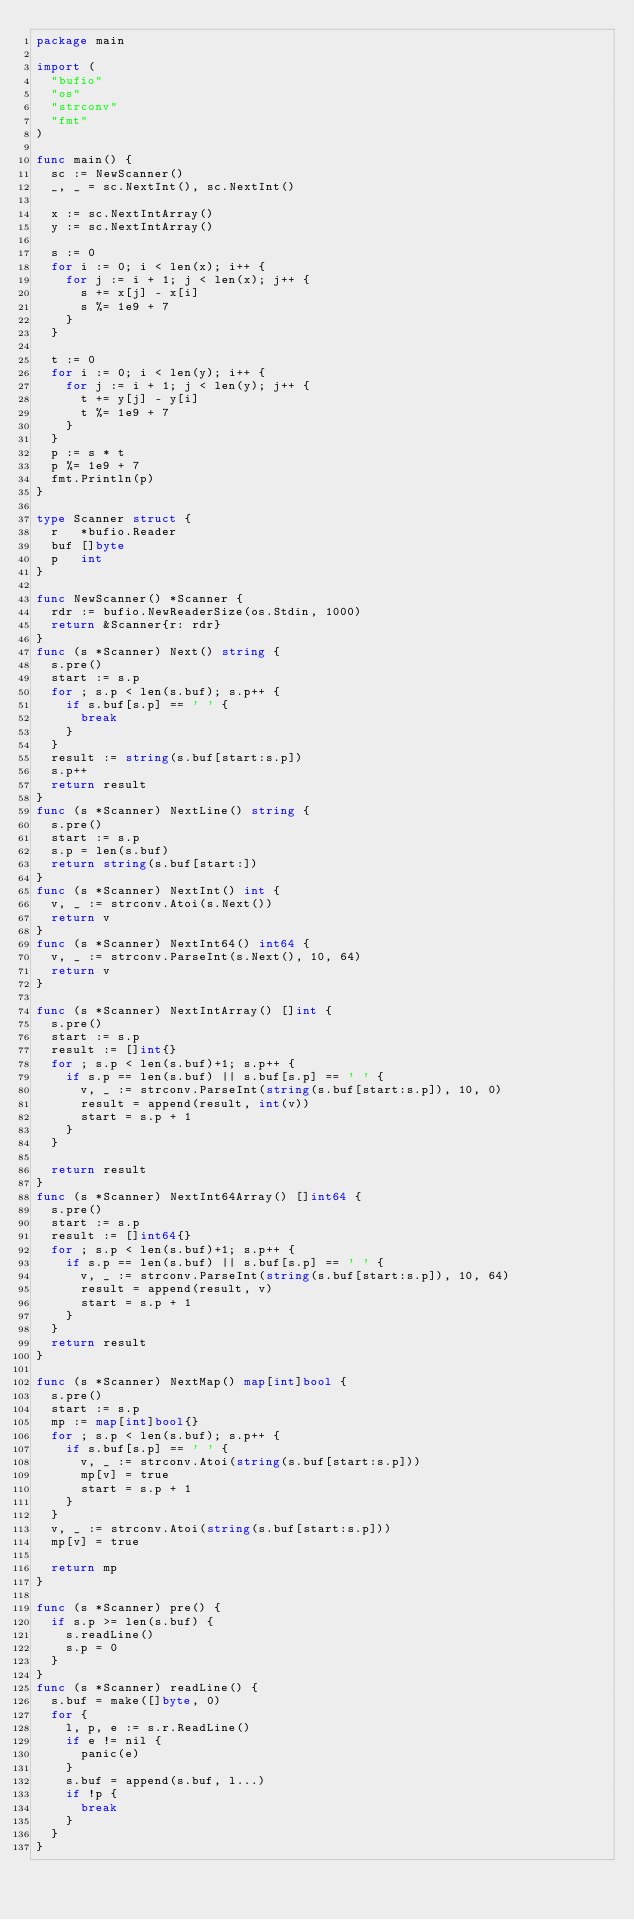<code> <loc_0><loc_0><loc_500><loc_500><_Go_>package main

import (
	"bufio"
	"os"
	"strconv"
	"fmt"
)

func main() {
	sc := NewScanner()
	_, _ = sc.NextInt(), sc.NextInt()

	x := sc.NextIntArray()
	y := sc.NextIntArray()

	s := 0
	for i := 0; i < len(x); i++ {
		for j := i + 1; j < len(x); j++ {
			s += x[j] - x[i]
			s %= 1e9 + 7
		}
	}

	t := 0
	for i := 0; i < len(y); i++ {
		for j := i + 1; j < len(y); j++ {
			t += y[j] - y[i]
			t %= 1e9 + 7
		}
	}
	p := s * t
	p %= 1e9 + 7
	fmt.Println(p)
}

type Scanner struct {
	r   *bufio.Reader
	buf []byte
	p   int
}

func NewScanner() *Scanner {
	rdr := bufio.NewReaderSize(os.Stdin, 1000)
	return &Scanner{r: rdr}
}
func (s *Scanner) Next() string {
	s.pre()
	start := s.p
	for ; s.p < len(s.buf); s.p++ {
		if s.buf[s.p] == ' ' {
			break
		}
	}
	result := string(s.buf[start:s.p])
	s.p++
	return result
}
func (s *Scanner) NextLine() string {
	s.pre()
	start := s.p
	s.p = len(s.buf)
	return string(s.buf[start:])
}
func (s *Scanner) NextInt() int {
	v, _ := strconv.Atoi(s.Next())
	return v
}
func (s *Scanner) NextInt64() int64 {
	v, _ := strconv.ParseInt(s.Next(), 10, 64)
	return v
}

func (s *Scanner) NextIntArray() []int {
	s.pre()
	start := s.p
	result := []int{}
	for ; s.p < len(s.buf)+1; s.p++ {
		if s.p == len(s.buf) || s.buf[s.p] == ' ' {
			v, _ := strconv.ParseInt(string(s.buf[start:s.p]), 10, 0)
			result = append(result, int(v))
			start = s.p + 1
		}
	}

	return result
}
func (s *Scanner) NextInt64Array() []int64 {
	s.pre()
	start := s.p
	result := []int64{}
	for ; s.p < len(s.buf)+1; s.p++ {
		if s.p == len(s.buf) || s.buf[s.p] == ' ' {
			v, _ := strconv.ParseInt(string(s.buf[start:s.p]), 10, 64)
			result = append(result, v)
			start = s.p + 1
		}
	}
	return result
}

func (s *Scanner) NextMap() map[int]bool {
	s.pre()
	start := s.p
	mp := map[int]bool{}
	for ; s.p < len(s.buf); s.p++ {
		if s.buf[s.p] == ' ' {
			v, _ := strconv.Atoi(string(s.buf[start:s.p]))
			mp[v] = true
			start = s.p + 1
		}
	}
	v, _ := strconv.Atoi(string(s.buf[start:s.p]))
	mp[v] = true

	return mp
}

func (s *Scanner) pre() {
	if s.p >= len(s.buf) {
		s.readLine()
		s.p = 0
	}
}
func (s *Scanner) readLine() {
	s.buf = make([]byte, 0)
	for {
		l, p, e := s.r.ReadLine()
		if e != nil {
			panic(e)
		}
		s.buf = append(s.buf, l...)
		if !p {
			break
		}
	}
}
</code> 